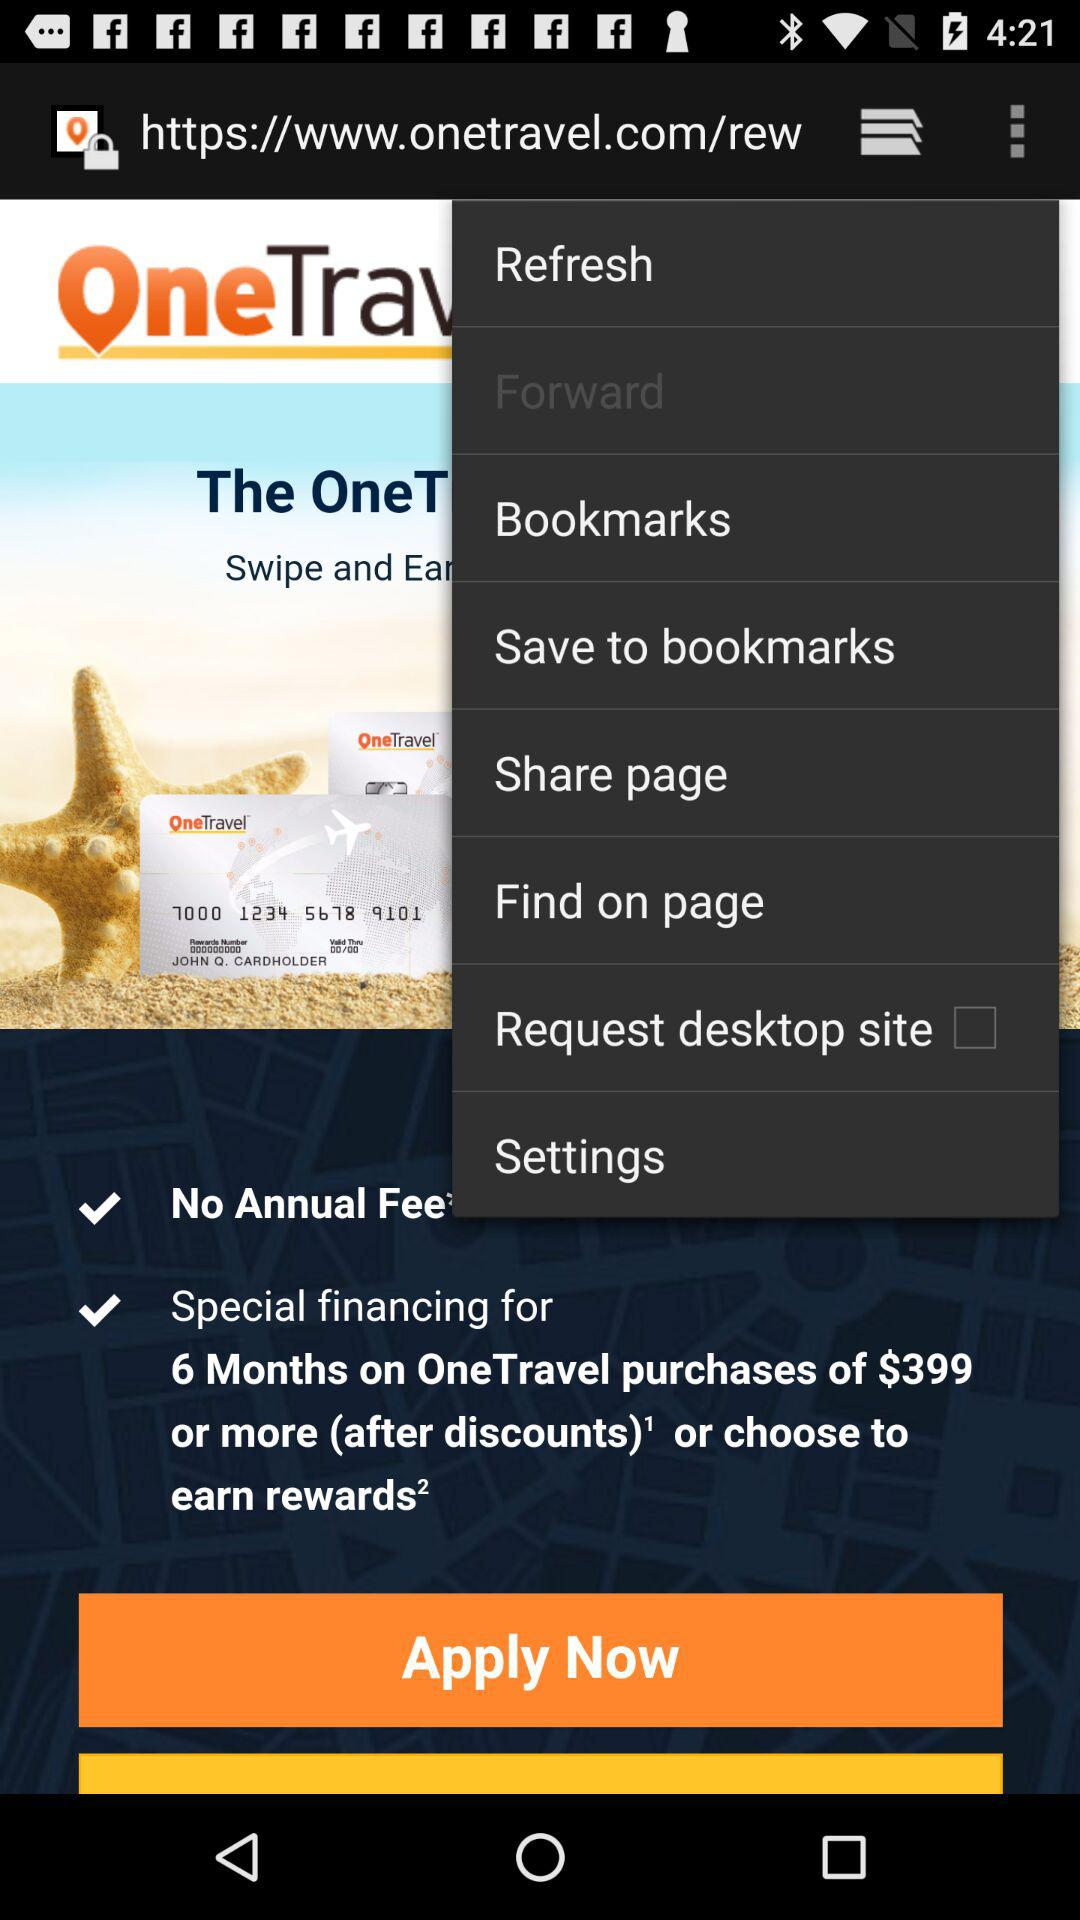What's the annual fee? There is no annual fee. 